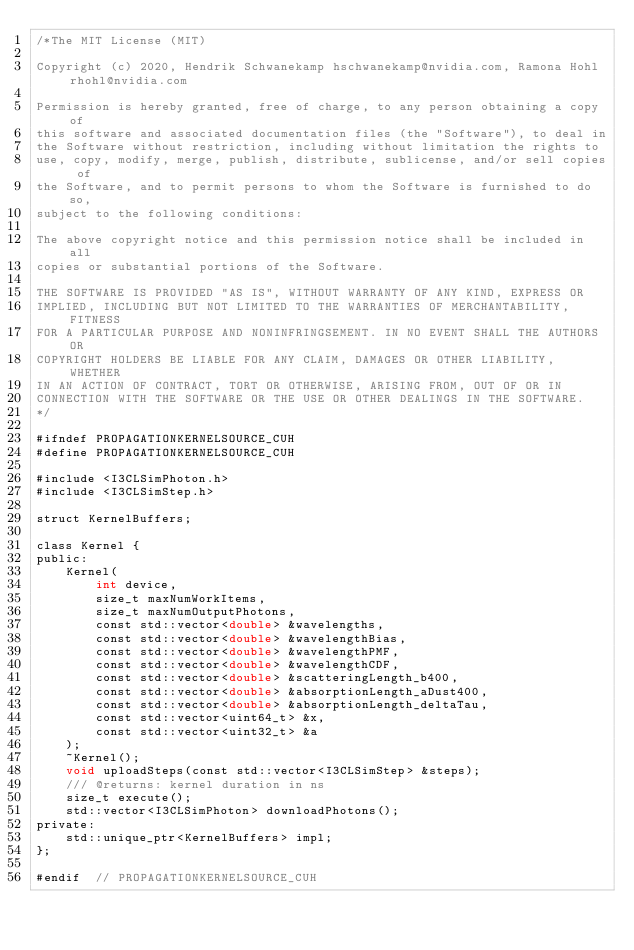Convert code to text. <code><loc_0><loc_0><loc_500><loc_500><_Cuda_>/*The MIT License (MIT)

Copyright (c) 2020, Hendrik Schwanekamp hschwanekamp@nvidia.com, Ramona Hohl rhohl@nvidia.com

Permission is hereby granted, free of charge, to any person obtaining a copy of
this software and associated documentation files (the "Software"), to deal in
the Software without restriction, including without limitation the rights to
use, copy, modify, merge, publish, distribute, sublicense, and/or sell copies of
the Software, and to permit persons to whom the Software is furnished to do so,
subject to the following conditions:

The above copyright notice and this permission notice shall be included in all
copies or substantial portions of the Software.

THE SOFTWARE IS PROVIDED "AS IS", WITHOUT WARRANTY OF ANY KIND, EXPRESS OR
IMPLIED, INCLUDING BUT NOT LIMITED TO THE WARRANTIES OF MERCHANTABILITY, FITNESS
FOR A PARTICULAR PURPOSE AND NONINFRINGSEMENT. IN NO EVENT SHALL THE AUTHORS OR
COPYRIGHT HOLDERS BE LIABLE FOR ANY CLAIM, DAMAGES OR OTHER LIABILITY, WHETHER
IN AN ACTION OF CONTRACT, TORT OR OTHERWISE, ARISING FROM, OUT OF OR IN
CONNECTION WITH THE SOFTWARE OR THE USE OR OTHER DEALINGS IN THE SOFTWARE.
*/

#ifndef PROPAGATIONKERNELSOURCE_CUH
#define PROPAGATIONKERNELSOURCE_CUH

#include <I3CLSimPhoton.h>
#include <I3CLSimStep.h>

struct KernelBuffers;

class Kernel {
public:
    Kernel(
        int device,
        size_t maxNumWorkItems,
        size_t maxNumOutputPhotons,
        const std::vector<double> &wavelengths,
        const std::vector<double> &wavelengthBias,
        const std::vector<double> &wavelengthPMF,
        const std::vector<double> &wavelengthCDF,
        const std::vector<double> &scatteringLength_b400,
        const std::vector<double> &absorptionLength_aDust400,
        const std::vector<double> &absorptionLength_deltaTau,
        const std::vector<uint64_t> &x,
        const std::vector<uint32_t> &a
    );
    ~Kernel();
    void uploadSteps(const std::vector<I3CLSimStep> &steps);
    /// @returns: kernel duration in ns
    size_t execute();
    std::vector<I3CLSimPhoton> downloadPhotons();
private:
    std::unique_ptr<KernelBuffers> impl;
};

#endif  // PROPAGATIONKERNELSOURCE_CUH</code> 